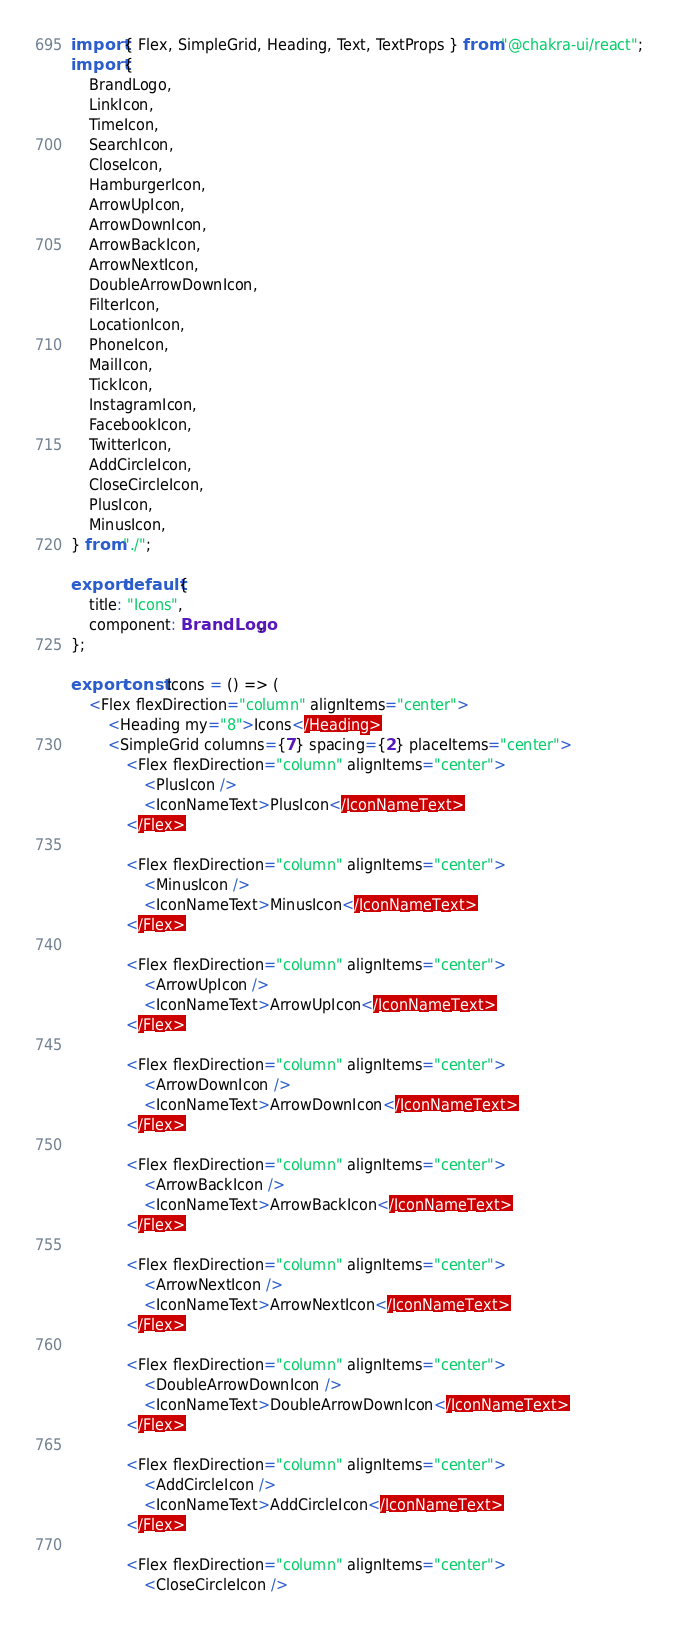Convert code to text. <code><loc_0><loc_0><loc_500><loc_500><_TypeScript_>import { Flex, SimpleGrid, Heading, Text, TextProps } from "@chakra-ui/react";
import {
    BrandLogo,
    LinkIcon,
    TimeIcon,
    SearchIcon,
    CloseIcon,
    HamburgerIcon,
    ArrowUpIcon,
    ArrowDownIcon,
    ArrowBackIcon,
    ArrowNextIcon,
    DoubleArrowDownIcon,
    FilterIcon,
    LocationIcon,
    PhoneIcon,
    MailIcon,
    TickIcon,
    InstagramIcon,
    FacebookIcon,
    TwitterIcon,
    AddCircleIcon,
    CloseCircleIcon,
    PlusIcon,
    MinusIcon,
} from "./";

export default {
    title: "Icons",
    component: BrandLogo,
};

export const Icons = () => (
    <Flex flexDirection="column" alignItems="center">
        <Heading my="8">Icons</Heading>
        <SimpleGrid columns={7} spacing={2} placeItems="center">
            <Flex flexDirection="column" alignItems="center">
                <PlusIcon />
                <IconNameText>PlusIcon</IconNameText>
            </Flex>

            <Flex flexDirection="column" alignItems="center">
                <MinusIcon />
                <IconNameText>MinusIcon</IconNameText>
            </Flex>

            <Flex flexDirection="column" alignItems="center">
                <ArrowUpIcon />
                <IconNameText>ArrowUpIcon</IconNameText>
            </Flex>

            <Flex flexDirection="column" alignItems="center">
                <ArrowDownIcon />
                <IconNameText>ArrowDownIcon</IconNameText>
            </Flex>

            <Flex flexDirection="column" alignItems="center">
                <ArrowBackIcon />
                <IconNameText>ArrowBackIcon</IconNameText>
            </Flex>

            <Flex flexDirection="column" alignItems="center">
                <ArrowNextIcon />
                <IconNameText>ArrowNextIcon</IconNameText>
            </Flex>

            <Flex flexDirection="column" alignItems="center">
                <DoubleArrowDownIcon />
                <IconNameText>DoubleArrowDownIcon</IconNameText>
            </Flex>

            <Flex flexDirection="column" alignItems="center">
                <AddCircleIcon />
                <IconNameText>AddCircleIcon</IconNameText>
            </Flex>

            <Flex flexDirection="column" alignItems="center">
                <CloseCircleIcon /></code> 